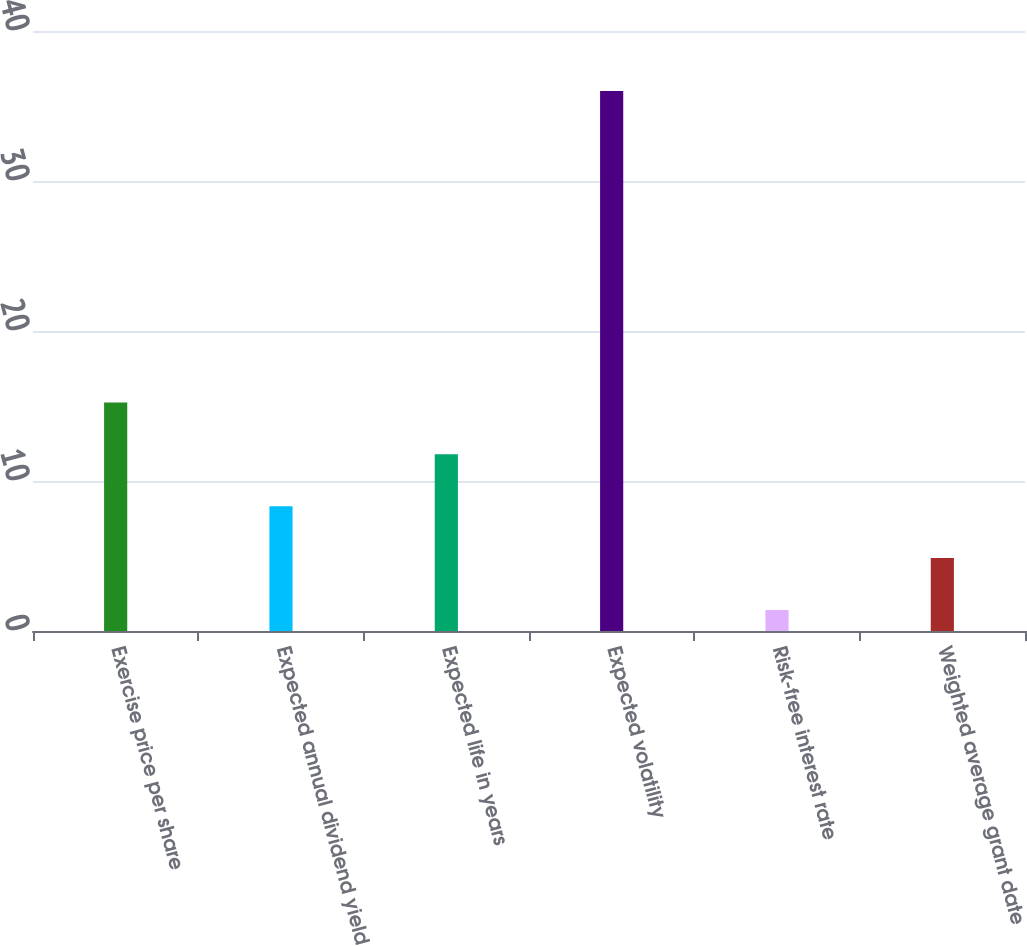Convert chart. <chart><loc_0><loc_0><loc_500><loc_500><bar_chart><fcel>Exercise price per share<fcel>Expected annual dividend yield<fcel>Expected life in years<fcel>Expected volatility<fcel>Risk-free interest rate<fcel>Weighted average grant date<nl><fcel>15.24<fcel>8.32<fcel>11.78<fcel>36<fcel>1.4<fcel>4.86<nl></chart> 